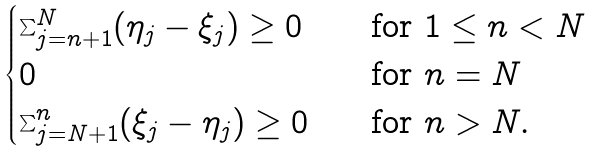<formula> <loc_0><loc_0><loc_500><loc_500>\begin{cases} \sum _ { j = n + 1 } ^ { N } ( \eta _ { j } - \xi _ { j } ) \geq 0 \quad & \text {for } 1 \leq n < N \\ 0 & \text {for } n = N \\ \sum _ { j = N + 1 } ^ { n } ( \xi _ { j } - \eta _ { j } ) \geq 0 & \text {for } n > N . \end{cases}</formula> 